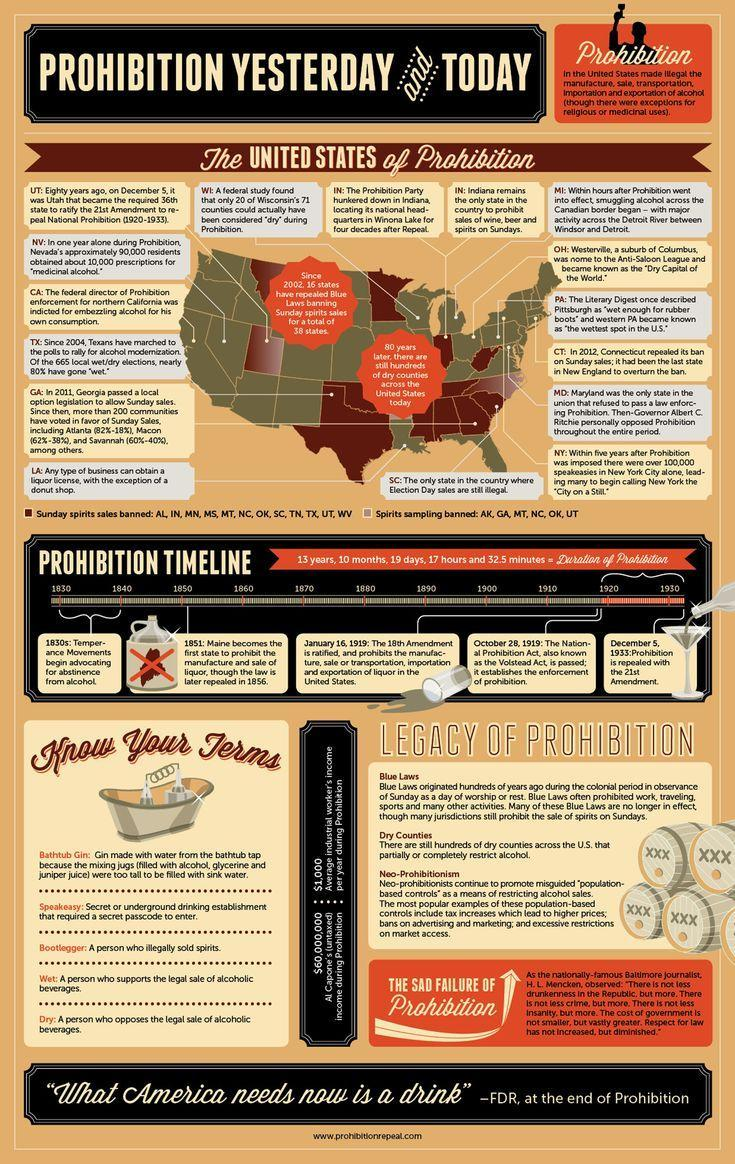How many states have banned spirits sampling?
Answer the question with a short phrase. 5 What was the time period of the Temperance movements ? 1830-1840 Which year did Maine ban the selling liquor ? 1851 How many states have banned Sunday spirits sales? 12 When was the prohibition on liquor revoked ? December 5, 1933 